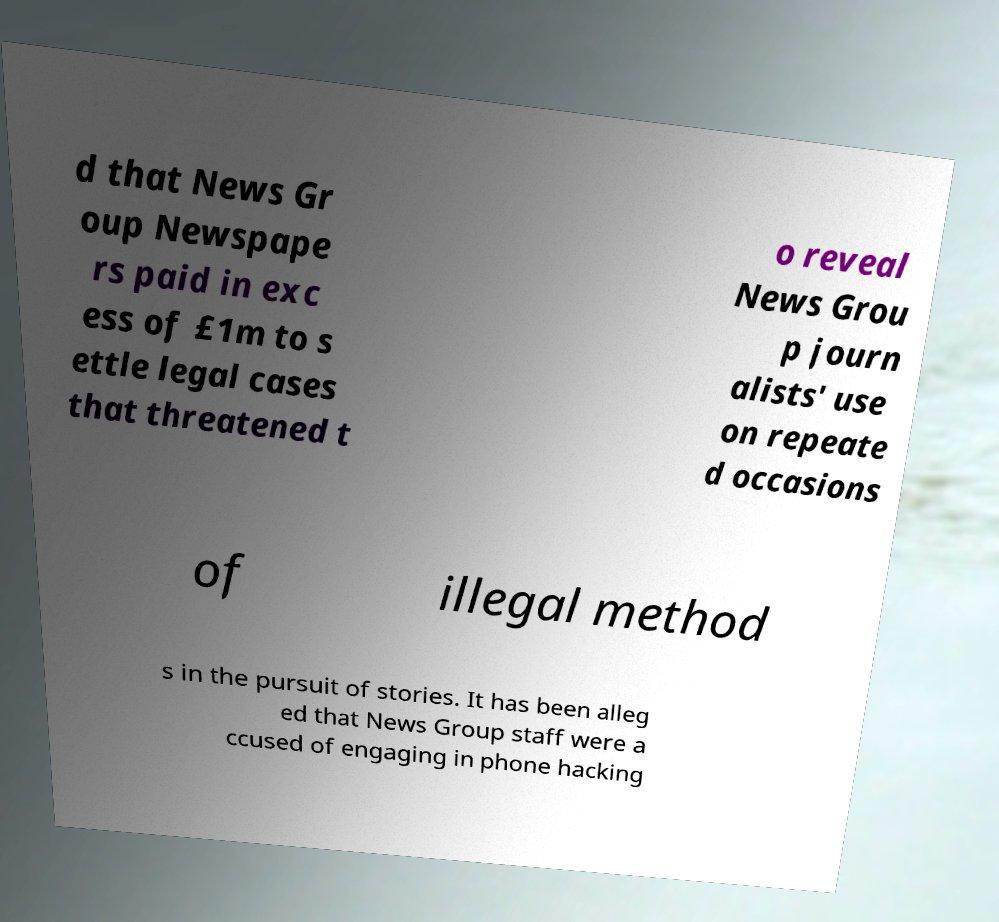I need the written content from this picture converted into text. Can you do that? d that News Gr oup Newspape rs paid in exc ess of £1m to s ettle legal cases that threatened t o reveal News Grou p journ alists' use on repeate d occasions of illegal method s in the pursuit of stories. It has been alleg ed that News Group staff were a ccused of engaging in phone hacking 